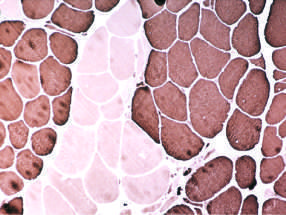do portal tracts and the periportal parenchyma appear that all share the same fiber type (fiber type grouping) with ongoing denervation and reinnervation?
Answer the question using a single word or phrase. No 